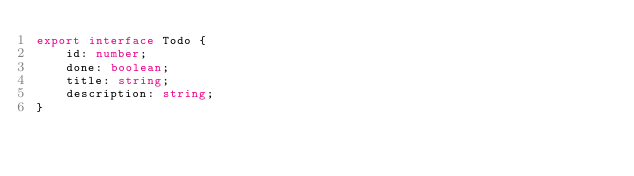<code> <loc_0><loc_0><loc_500><loc_500><_TypeScript_>export interface Todo {
    id: number;
    done: boolean;
    title: string;
    description: string;
}</code> 